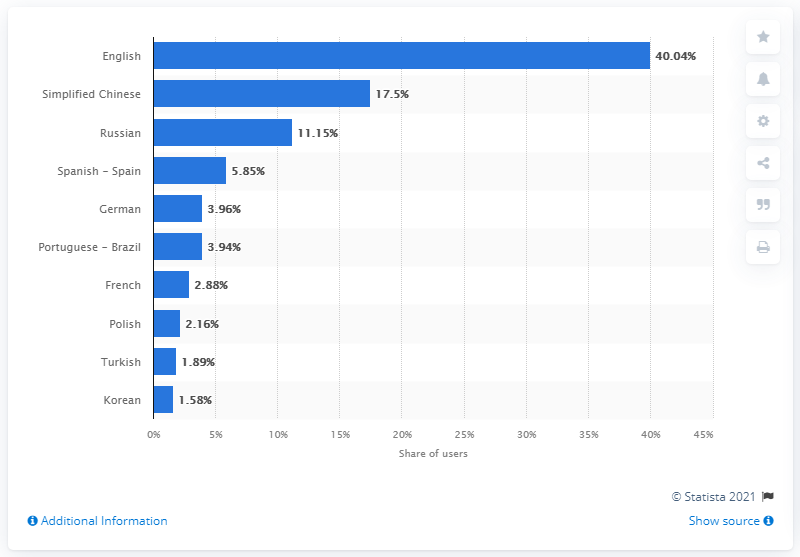Identify some key points in this picture. As of May 2021, English was Steam's main language. The second language in terms of usage was ranked at 17.5% and was Simplified Chinese. 